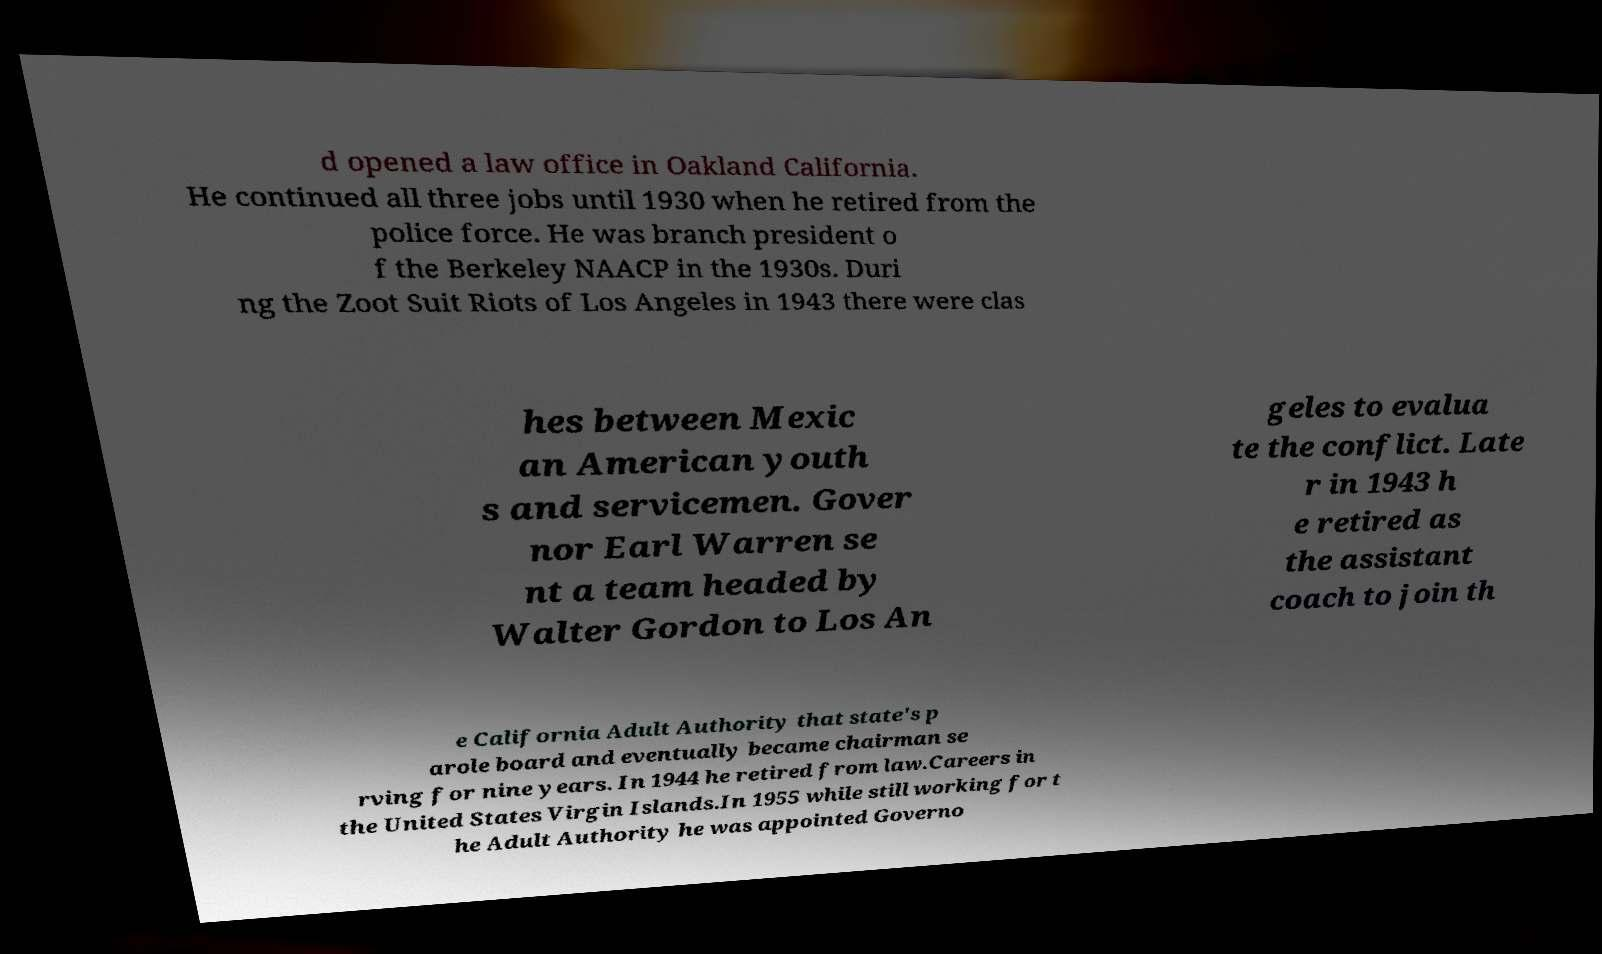Can you accurately transcribe the text from the provided image for me? d opened a law office in Oakland California. He continued all three jobs until 1930 when he retired from the police force. He was branch president o f the Berkeley NAACP in the 1930s. Duri ng the Zoot Suit Riots of Los Angeles in 1943 there were clas hes between Mexic an American youth s and servicemen. Gover nor Earl Warren se nt a team headed by Walter Gordon to Los An geles to evalua te the conflict. Late r in 1943 h e retired as the assistant coach to join th e California Adult Authority that state's p arole board and eventually became chairman se rving for nine years. In 1944 he retired from law.Careers in the United States Virgin Islands.In 1955 while still working for t he Adult Authority he was appointed Governo 